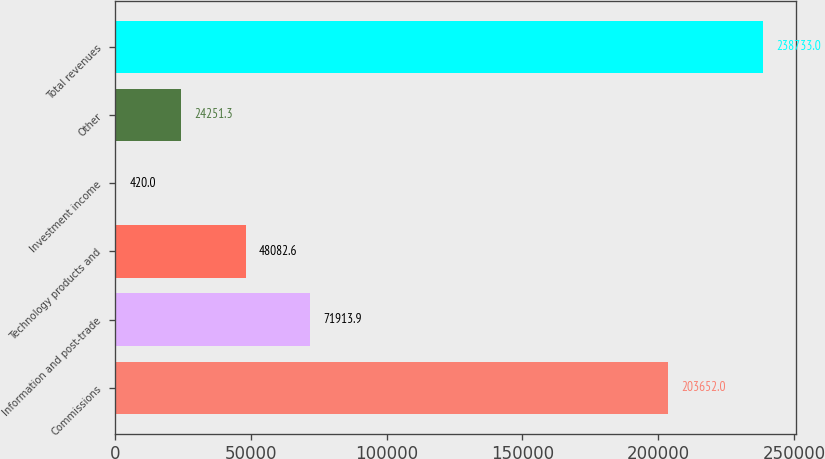<chart> <loc_0><loc_0><loc_500><loc_500><bar_chart><fcel>Commissions<fcel>Information and post-trade<fcel>Technology products and<fcel>Investment income<fcel>Other<fcel>Total revenues<nl><fcel>203652<fcel>71913.9<fcel>48082.6<fcel>420<fcel>24251.3<fcel>238733<nl></chart> 